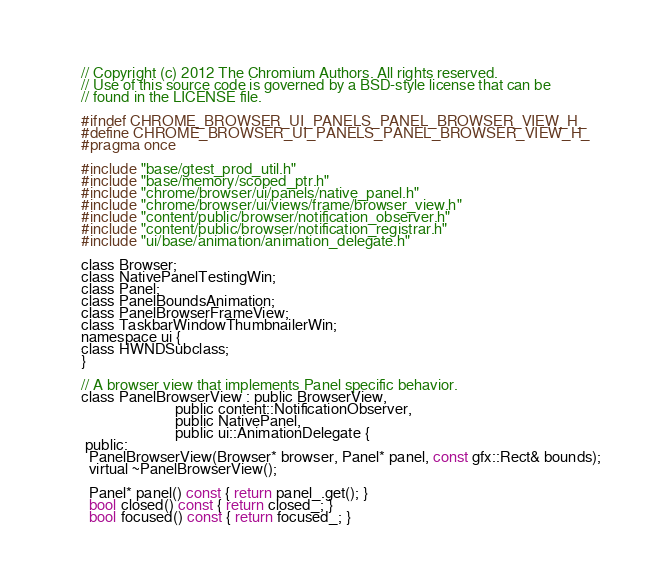Convert code to text. <code><loc_0><loc_0><loc_500><loc_500><_C_>// Copyright (c) 2012 The Chromium Authors. All rights reserved.
// Use of this source code is governed by a BSD-style license that can be
// found in the LICENSE file.

#ifndef CHROME_BROWSER_UI_PANELS_PANEL_BROWSER_VIEW_H_
#define CHROME_BROWSER_UI_PANELS_PANEL_BROWSER_VIEW_H_
#pragma once

#include "base/gtest_prod_util.h"
#include "base/memory/scoped_ptr.h"
#include "chrome/browser/ui/panels/native_panel.h"
#include "chrome/browser/ui/views/frame/browser_view.h"
#include "content/public/browser/notification_observer.h"
#include "content/public/browser/notification_registrar.h"
#include "ui/base/animation/animation_delegate.h"

class Browser;
class NativePanelTestingWin;
class Panel;
class PanelBoundsAnimation;
class PanelBrowserFrameView;
class TaskbarWindowThumbnailerWin;
namespace ui {
class HWNDSubclass;
}

// A browser view that implements Panel specific behavior.
class PanelBrowserView : public BrowserView,
                         public content::NotificationObserver,
                         public NativePanel,
                         public ui::AnimationDelegate {
 public:
  PanelBrowserView(Browser* browser, Panel* panel, const gfx::Rect& bounds);
  virtual ~PanelBrowserView();

  Panel* panel() const { return panel_.get(); }
  bool closed() const { return closed_; }
  bool focused() const { return focused_; }</code> 